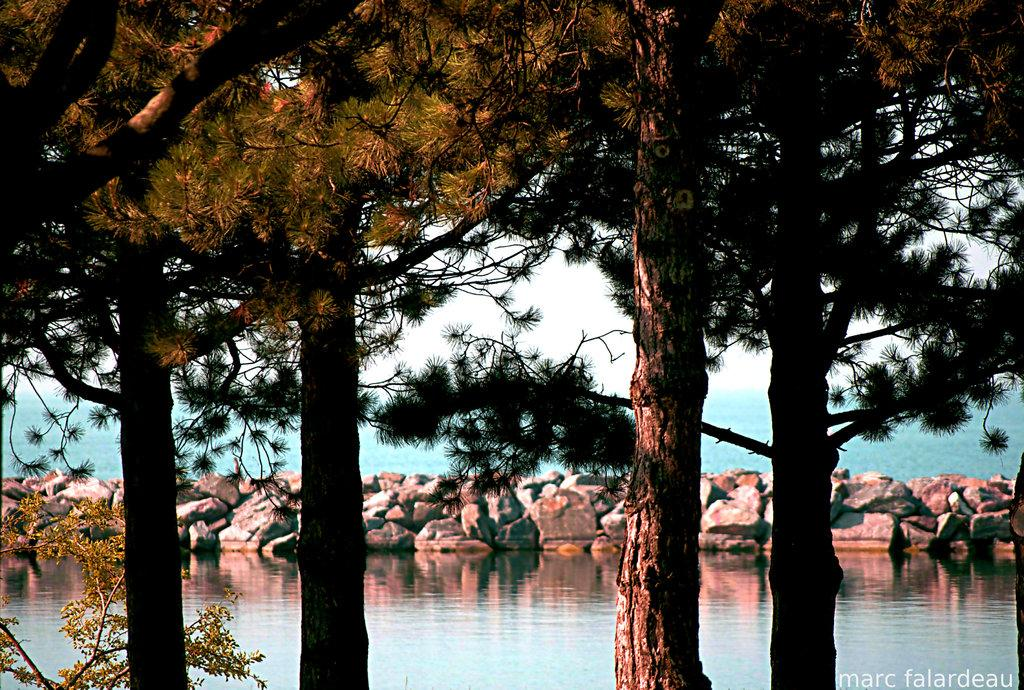What type of natural elements can be seen in the image? There are trees and water visible in the image. What other objects can be seen in the background of the image? There are stones in the background of the image. How would you describe the color of the sky in the image? The sky appears to be white in color. How many horses are present in the room depicted in the image? There are no horses or rooms present in the image; it features trees, water, stones, and a white sky. 